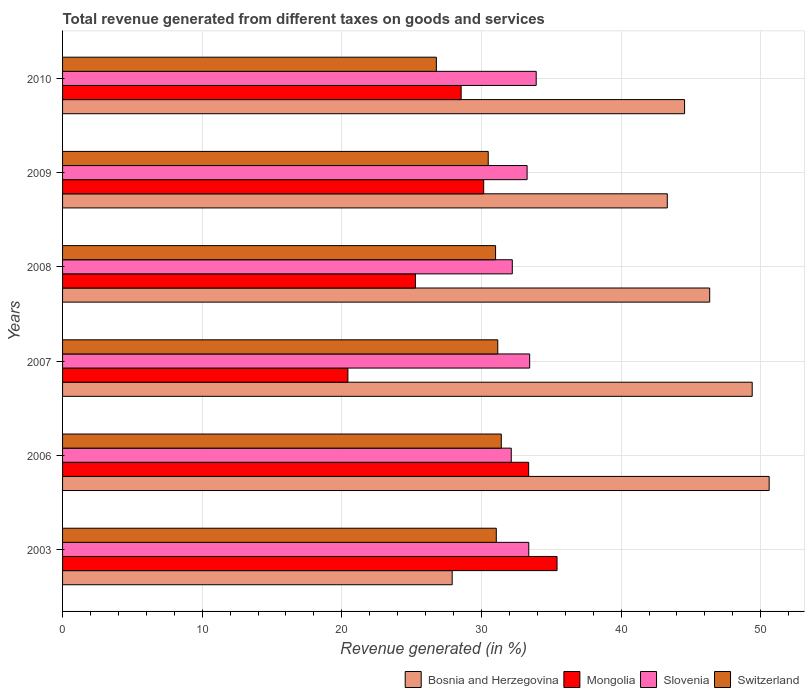Are the number of bars on each tick of the Y-axis equal?
Ensure brevity in your answer.  Yes. How many bars are there on the 2nd tick from the top?
Make the answer very short. 4. What is the label of the 1st group of bars from the top?
Provide a short and direct response. 2010. What is the total revenue generated in Switzerland in 2009?
Offer a terse response. 30.48. Across all years, what is the maximum total revenue generated in Bosnia and Herzegovina?
Offer a terse response. 50.6. Across all years, what is the minimum total revenue generated in Bosnia and Herzegovina?
Keep it short and to the point. 27.9. In which year was the total revenue generated in Slovenia minimum?
Provide a succinct answer. 2006. What is the total total revenue generated in Bosnia and Herzegovina in the graph?
Give a very brief answer. 262.08. What is the difference between the total revenue generated in Mongolia in 2007 and that in 2008?
Your answer should be very brief. -4.84. What is the difference between the total revenue generated in Slovenia in 2006 and the total revenue generated in Bosnia and Herzegovina in 2003?
Provide a short and direct response. 4.23. What is the average total revenue generated in Switzerland per year?
Your response must be concise. 30.32. In the year 2003, what is the difference between the total revenue generated in Switzerland and total revenue generated in Bosnia and Herzegovina?
Offer a terse response. 3.16. What is the ratio of the total revenue generated in Slovenia in 2009 to that in 2010?
Provide a succinct answer. 0.98. Is the difference between the total revenue generated in Switzerland in 2003 and 2009 greater than the difference between the total revenue generated in Bosnia and Herzegovina in 2003 and 2009?
Your answer should be very brief. Yes. What is the difference between the highest and the second highest total revenue generated in Slovenia?
Provide a short and direct response. 0.47. What is the difference between the highest and the lowest total revenue generated in Bosnia and Herzegovina?
Offer a very short reply. 22.7. In how many years, is the total revenue generated in Switzerland greater than the average total revenue generated in Switzerland taken over all years?
Your answer should be compact. 5. Is it the case that in every year, the sum of the total revenue generated in Switzerland and total revenue generated in Mongolia is greater than the sum of total revenue generated in Bosnia and Herzegovina and total revenue generated in Slovenia?
Ensure brevity in your answer.  No. What does the 3rd bar from the top in 2010 represents?
Give a very brief answer. Mongolia. What does the 1st bar from the bottom in 2010 represents?
Provide a short and direct response. Bosnia and Herzegovina. Is it the case that in every year, the sum of the total revenue generated in Bosnia and Herzegovina and total revenue generated in Switzerland is greater than the total revenue generated in Slovenia?
Your answer should be compact. Yes. How many years are there in the graph?
Offer a terse response. 6. What is the difference between two consecutive major ticks on the X-axis?
Keep it short and to the point. 10. Are the values on the major ticks of X-axis written in scientific E-notation?
Make the answer very short. No. How are the legend labels stacked?
Provide a short and direct response. Horizontal. What is the title of the graph?
Your response must be concise. Total revenue generated from different taxes on goods and services. What is the label or title of the X-axis?
Ensure brevity in your answer.  Revenue generated (in %). What is the label or title of the Y-axis?
Your response must be concise. Years. What is the Revenue generated (in %) in Bosnia and Herzegovina in 2003?
Ensure brevity in your answer.  27.9. What is the Revenue generated (in %) of Mongolia in 2003?
Your answer should be compact. 35.41. What is the Revenue generated (in %) of Slovenia in 2003?
Your answer should be very brief. 33.39. What is the Revenue generated (in %) of Switzerland in 2003?
Provide a succinct answer. 31.06. What is the Revenue generated (in %) of Bosnia and Herzegovina in 2006?
Provide a short and direct response. 50.6. What is the Revenue generated (in %) of Mongolia in 2006?
Offer a very short reply. 33.38. What is the Revenue generated (in %) of Slovenia in 2006?
Your answer should be very brief. 32.13. What is the Revenue generated (in %) of Switzerland in 2006?
Make the answer very short. 31.42. What is the Revenue generated (in %) in Bosnia and Herzegovina in 2007?
Keep it short and to the point. 49.39. What is the Revenue generated (in %) of Mongolia in 2007?
Your answer should be very brief. 20.43. What is the Revenue generated (in %) of Slovenia in 2007?
Your answer should be very brief. 33.45. What is the Revenue generated (in %) of Switzerland in 2007?
Make the answer very short. 31.17. What is the Revenue generated (in %) of Bosnia and Herzegovina in 2008?
Provide a short and direct response. 46.34. What is the Revenue generated (in %) of Mongolia in 2008?
Ensure brevity in your answer.  25.27. What is the Revenue generated (in %) in Slovenia in 2008?
Offer a terse response. 32.21. What is the Revenue generated (in %) of Switzerland in 2008?
Offer a very short reply. 31.01. What is the Revenue generated (in %) in Bosnia and Herzegovina in 2009?
Your answer should be compact. 43.31. What is the Revenue generated (in %) in Mongolia in 2009?
Your answer should be compact. 30.16. What is the Revenue generated (in %) in Slovenia in 2009?
Provide a short and direct response. 33.27. What is the Revenue generated (in %) of Switzerland in 2009?
Your answer should be very brief. 30.48. What is the Revenue generated (in %) in Bosnia and Herzegovina in 2010?
Your response must be concise. 44.54. What is the Revenue generated (in %) in Mongolia in 2010?
Give a very brief answer. 28.54. What is the Revenue generated (in %) of Slovenia in 2010?
Make the answer very short. 33.92. What is the Revenue generated (in %) in Switzerland in 2010?
Ensure brevity in your answer.  26.77. Across all years, what is the maximum Revenue generated (in %) in Bosnia and Herzegovina?
Provide a succinct answer. 50.6. Across all years, what is the maximum Revenue generated (in %) of Mongolia?
Offer a very short reply. 35.41. Across all years, what is the maximum Revenue generated (in %) of Slovenia?
Keep it short and to the point. 33.92. Across all years, what is the maximum Revenue generated (in %) in Switzerland?
Keep it short and to the point. 31.42. Across all years, what is the minimum Revenue generated (in %) of Bosnia and Herzegovina?
Make the answer very short. 27.9. Across all years, what is the minimum Revenue generated (in %) of Mongolia?
Make the answer very short. 20.43. Across all years, what is the minimum Revenue generated (in %) of Slovenia?
Offer a very short reply. 32.13. Across all years, what is the minimum Revenue generated (in %) of Switzerland?
Your answer should be compact. 26.77. What is the total Revenue generated (in %) of Bosnia and Herzegovina in the graph?
Ensure brevity in your answer.  262.08. What is the total Revenue generated (in %) of Mongolia in the graph?
Offer a very short reply. 173.19. What is the total Revenue generated (in %) in Slovenia in the graph?
Give a very brief answer. 198.36. What is the total Revenue generated (in %) in Switzerland in the graph?
Your response must be concise. 181.91. What is the difference between the Revenue generated (in %) in Bosnia and Herzegovina in 2003 and that in 2006?
Make the answer very short. -22.7. What is the difference between the Revenue generated (in %) of Mongolia in 2003 and that in 2006?
Make the answer very short. 2.03. What is the difference between the Revenue generated (in %) of Slovenia in 2003 and that in 2006?
Give a very brief answer. 1.25. What is the difference between the Revenue generated (in %) of Switzerland in 2003 and that in 2006?
Keep it short and to the point. -0.36. What is the difference between the Revenue generated (in %) of Bosnia and Herzegovina in 2003 and that in 2007?
Make the answer very short. -21.48. What is the difference between the Revenue generated (in %) in Mongolia in 2003 and that in 2007?
Ensure brevity in your answer.  14.98. What is the difference between the Revenue generated (in %) in Slovenia in 2003 and that in 2007?
Your answer should be very brief. -0.06. What is the difference between the Revenue generated (in %) of Switzerland in 2003 and that in 2007?
Offer a terse response. -0.11. What is the difference between the Revenue generated (in %) in Bosnia and Herzegovina in 2003 and that in 2008?
Offer a terse response. -18.44. What is the difference between the Revenue generated (in %) of Mongolia in 2003 and that in 2008?
Offer a terse response. 10.14. What is the difference between the Revenue generated (in %) of Slovenia in 2003 and that in 2008?
Offer a terse response. 1.18. What is the difference between the Revenue generated (in %) in Switzerland in 2003 and that in 2008?
Offer a very short reply. 0.05. What is the difference between the Revenue generated (in %) of Bosnia and Herzegovina in 2003 and that in 2009?
Your answer should be very brief. -15.4. What is the difference between the Revenue generated (in %) in Mongolia in 2003 and that in 2009?
Make the answer very short. 5.25. What is the difference between the Revenue generated (in %) in Slovenia in 2003 and that in 2009?
Make the answer very short. 0.12. What is the difference between the Revenue generated (in %) in Switzerland in 2003 and that in 2009?
Offer a very short reply. 0.58. What is the difference between the Revenue generated (in %) in Bosnia and Herzegovina in 2003 and that in 2010?
Provide a short and direct response. -16.64. What is the difference between the Revenue generated (in %) in Mongolia in 2003 and that in 2010?
Offer a very short reply. 6.87. What is the difference between the Revenue generated (in %) in Slovenia in 2003 and that in 2010?
Offer a very short reply. -0.53. What is the difference between the Revenue generated (in %) of Switzerland in 2003 and that in 2010?
Offer a terse response. 4.29. What is the difference between the Revenue generated (in %) of Bosnia and Herzegovina in 2006 and that in 2007?
Ensure brevity in your answer.  1.21. What is the difference between the Revenue generated (in %) in Mongolia in 2006 and that in 2007?
Offer a terse response. 12.94. What is the difference between the Revenue generated (in %) in Slovenia in 2006 and that in 2007?
Your answer should be compact. -1.32. What is the difference between the Revenue generated (in %) in Switzerland in 2006 and that in 2007?
Provide a short and direct response. 0.25. What is the difference between the Revenue generated (in %) of Bosnia and Herzegovina in 2006 and that in 2008?
Ensure brevity in your answer.  4.26. What is the difference between the Revenue generated (in %) in Mongolia in 2006 and that in 2008?
Make the answer very short. 8.11. What is the difference between the Revenue generated (in %) in Slovenia in 2006 and that in 2008?
Give a very brief answer. -0.07. What is the difference between the Revenue generated (in %) of Switzerland in 2006 and that in 2008?
Your answer should be compact. 0.41. What is the difference between the Revenue generated (in %) in Bosnia and Herzegovina in 2006 and that in 2009?
Make the answer very short. 7.3. What is the difference between the Revenue generated (in %) in Mongolia in 2006 and that in 2009?
Offer a very short reply. 3.22. What is the difference between the Revenue generated (in %) in Slovenia in 2006 and that in 2009?
Make the answer very short. -1.13. What is the difference between the Revenue generated (in %) in Switzerland in 2006 and that in 2009?
Your answer should be compact. 0.94. What is the difference between the Revenue generated (in %) of Bosnia and Herzegovina in 2006 and that in 2010?
Offer a terse response. 6.06. What is the difference between the Revenue generated (in %) of Mongolia in 2006 and that in 2010?
Ensure brevity in your answer.  4.83. What is the difference between the Revenue generated (in %) of Slovenia in 2006 and that in 2010?
Your answer should be compact. -1.79. What is the difference between the Revenue generated (in %) of Switzerland in 2006 and that in 2010?
Give a very brief answer. 4.65. What is the difference between the Revenue generated (in %) of Bosnia and Herzegovina in 2007 and that in 2008?
Offer a terse response. 3.04. What is the difference between the Revenue generated (in %) in Mongolia in 2007 and that in 2008?
Provide a short and direct response. -4.84. What is the difference between the Revenue generated (in %) of Slovenia in 2007 and that in 2008?
Ensure brevity in your answer.  1.24. What is the difference between the Revenue generated (in %) in Switzerland in 2007 and that in 2008?
Keep it short and to the point. 0.16. What is the difference between the Revenue generated (in %) in Bosnia and Herzegovina in 2007 and that in 2009?
Provide a short and direct response. 6.08. What is the difference between the Revenue generated (in %) in Mongolia in 2007 and that in 2009?
Offer a very short reply. -9.73. What is the difference between the Revenue generated (in %) in Slovenia in 2007 and that in 2009?
Your response must be concise. 0.18. What is the difference between the Revenue generated (in %) in Switzerland in 2007 and that in 2009?
Provide a succinct answer. 0.68. What is the difference between the Revenue generated (in %) in Bosnia and Herzegovina in 2007 and that in 2010?
Ensure brevity in your answer.  4.84. What is the difference between the Revenue generated (in %) in Mongolia in 2007 and that in 2010?
Make the answer very short. -8.11. What is the difference between the Revenue generated (in %) in Slovenia in 2007 and that in 2010?
Your answer should be compact. -0.47. What is the difference between the Revenue generated (in %) in Switzerland in 2007 and that in 2010?
Your answer should be compact. 4.4. What is the difference between the Revenue generated (in %) of Bosnia and Herzegovina in 2008 and that in 2009?
Your answer should be very brief. 3.04. What is the difference between the Revenue generated (in %) of Mongolia in 2008 and that in 2009?
Your answer should be very brief. -4.89. What is the difference between the Revenue generated (in %) in Slovenia in 2008 and that in 2009?
Offer a terse response. -1.06. What is the difference between the Revenue generated (in %) in Switzerland in 2008 and that in 2009?
Your answer should be very brief. 0.53. What is the difference between the Revenue generated (in %) in Bosnia and Herzegovina in 2008 and that in 2010?
Offer a very short reply. 1.8. What is the difference between the Revenue generated (in %) in Mongolia in 2008 and that in 2010?
Your answer should be very brief. -3.27. What is the difference between the Revenue generated (in %) in Slovenia in 2008 and that in 2010?
Offer a very short reply. -1.71. What is the difference between the Revenue generated (in %) of Switzerland in 2008 and that in 2010?
Ensure brevity in your answer.  4.24. What is the difference between the Revenue generated (in %) of Bosnia and Herzegovina in 2009 and that in 2010?
Keep it short and to the point. -1.24. What is the difference between the Revenue generated (in %) in Mongolia in 2009 and that in 2010?
Give a very brief answer. 1.61. What is the difference between the Revenue generated (in %) of Slovenia in 2009 and that in 2010?
Keep it short and to the point. -0.65. What is the difference between the Revenue generated (in %) in Switzerland in 2009 and that in 2010?
Offer a very short reply. 3.71. What is the difference between the Revenue generated (in %) of Bosnia and Herzegovina in 2003 and the Revenue generated (in %) of Mongolia in 2006?
Your answer should be compact. -5.48. What is the difference between the Revenue generated (in %) in Bosnia and Herzegovina in 2003 and the Revenue generated (in %) in Slovenia in 2006?
Give a very brief answer. -4.23. What is the difference between the Revenue generated (in %) of Bosnia and Herzegovina in 2003 and the Revenue generated (in %) of Switzerland in 2006?
Offer a very short reply. -3.52. What is the difference between the Revenue generated (in %) of Mongolia in 2003 and the Revenue generated (in %) of Slovenia in 2006?
Provide a short and direct response. 3.28. What is the difference between the Revenue generated (in %) in Mongolia in 2003 and the Revenue generated (in %) in Switzerland in 2006?
Keep it short and to the point. 3.99. What is the difference between the Revenue generated (in %) in Slovenia in 2003 and the Revenue generated (in %) in Switzerland in 2006?
Provide a short and direct response. 1.97. What is the difference between the Revenue generated (in %) of Bosnia and Herzegovina in 2003 and the Revenue generated (in %) of Mongolia in 2007?
Ensure brevity in your answer.  7.47. What is the difference between the Revenue generated (in %) of Bosnia and Herzegovina in 2003 and the Revenue generated (in %) of Slovenia in 2007?
Provide a succinct answer. -5.55. What is the difference between the Revenue generated (in %) in Bosnia and Herzegovina in 2003 and the Revenue generated (in %) in Switzerland in 2007?
Provide a succinct answer. -3.26. What is the difference between the Revenue generated (in %) of Mongolia in 2003 and the Revenue generated (in %) of Slovenia in 2007?
Make the answer very short. 1.96. What is the difference between the Revenue generated (in %) in Mongolia in 2003 and the Revenue generated (in %) in Switzerland in 2007?
Your response must be concise. 4.24. What is the difference between the Revenue generated (in %) in Slovenia in 2003 and the Revenue generated (in %) in Switzerland in 2007?
Provide a short and direct response. 2.22. What is the difference between the Revenue generated (in %) of Bosnia and Herzegovina in 2003 and the Revenue generated (in %) of Mongolia in 2008?
Offer a very short reply. 2.63. What is the difference between the Revenue generated (in %) in Bosnia and Herzegovina in 2003 and the Revenue generated (in %) in Slovenia in 2008?
Provide a short and direct response. -4.3. What is the difference between the Revenue generated (in %) in Bosnia and Herzegovina in 2003 and the Revenue generated (in %) in Switzerland in 2008?
Your response must be concise. -3.11. What is the difference between the Revenue generated (in %) in Mongolia in 2003 and the Revenue generated (in %) in Slovenia in 2008?
Offer a very short reply. 3.2. What is the difference between the Revenue generated (in %) in Mongolia in 2003 and the Revenue generated (in %) in Switzerland in 2008?
Ensure brevity in your answer.  4.4. What is the difference between the Revenue generated (in %) in Slovenia in 2003 and the Revenue generated (in %) in Switzerland in 2008?
Ensure brevity in your answer.  2.38. What is the difference between the Revenue generated (in %) in Bosnia and Herzegovina in 2003 and the Revenue generated (in %) in Mongolia in 2009?
Keep it short and to the point. -2.26. What is the difference between the Revenue generated (in %) of Bosnia and Herzegovina in 2003 and the Revenue generated (in %) of Slovenia in 2009?
Give a very brief answer. -5.37. What is the difference between the Revenue generated (in %) of Bosnia and Herzegovina in 2003 and the Revenue generated (in %) of Switzerland in 2009?
Your response must be concise. -2.58. What is the difference between the Revenue generated (in %) in Mongolia in 2003 and the Revenue generated (in %) in Slovenia in 2009?
Your response must be concise. 2.14. What is the difference between the Revenue generated (in %) of Mongolia in 2003 and the Revenue generated (in %) of Switzerland in 2009?
Offer a terse response. 4.93. What is the difference between the Revenue generated (in %) of Slovenia in 2003 and the Revenue generated (in %) of Switzerland in 2009?
Give a very brief answer. 2.9. What is the difference between the Revenue generated (in %) in Bosnia and Herzegovina in 2003 and the Revenue generated (in %) in Mongolia in 2010?
Your response must be concise. -0.64. What is the difference between the Revenue generated (in %) of Bosnia and Herzegovina in 2003 and the Revenue generated (in %) of Slovenia in 2010?
Provide a short and direct response. -6.02. What is the difference between the Revenue generated (in %) in Bosnia and Herzegovina in 2003 and the Revenue generated (in %) in Switzerland in 2010?
Your answer should be compact. 1.13. What is the difference between the Revenue generated (in %) in Mongolia in 2003 and the Revenue generated (in %) in Slovenia in 2010?
Keep it short and to the point. 1.49. What is the difference between the Revenue generated (in %) in Mongolia in 2003 and the Revenue generated (in %) in Switzerland in 2010?
Keep it short and to the point. 8.64. What is the difference between the Revenue generated (in %) in Slovenia in 2003 and the Revenue generated (in %) in Switzerland in 2010?
Your answer should be very brief. 6.62. What is the difference between the Revenue generated (in %) of Bosnia and Herzegovina in 2006 and the Revenue generated (in %) of Mongolia in 2007?
Your answer should be very brief. 30.17. What is the difference between the Revenue generated (in %) in Bosnia and Herzegovina in 2006 and the Revenue generated (in %) in Slovenia in 2007?
Keep it short and to the point. 17.15. What is the difference between the Revenue generated (in %) of Bosnia and Herzegovina in 2006 and the Revenue generated (in %) of Switzerland in 2007?
Give a very brief answer. 19.43. What is the difference between the Revenue generated (in %) of Mongolia in 2006 and the Revenue generated (in %) of Slovenia in 2007?
Keep it short and to the point. -0.07. What is the difference between the Revenue generated (in %) in Mongolia in 2006 and the Revenue generated (in %) in Switzerland in 2007?
Your answer should be compact. 2.21. What is the difference between the Revenue generated (in %) in Slovenia in 2006 and the Revenue generated (in %) in Switzerland in 2007?
Make the answer very short. 0.97. What is the difference between the Revenue generated (in %) in Bosnia and Herzegovina in 2006 and the Revenue generated (in %) in Mongolia in 2008?
Your answer should be very brief. 25.33. What is the difference between the Revenue generated (in %) in Bosnia and Herzegovina in 2006 and the Revenue generated (in %) in Slovenia in 2008?
Provide a succinct answer. 18.39. What is the difference between the Revenue generated (in %) of Bosnia and Herzegovina in 2006 and the Revenue generated (in %) of Switzerland in 2008?
Offer a terse response. 19.59. What is the difference between the Revenue generated (in %) in Mongolia in 2006 and the Revenue generated (in %) in Slovenia in 2008?
Give a very brief answer. 1.17. What is the difference between the Revenue generated (in %) of Mongolia in 2006 and the Revenue generated (in %) of Switzerland in 2008?
Give a very brief answer. 2.37. What is the difference between the Revenue generated (in %) of Slovenia in 2006 and the Revenue generated (in %) of Switzerland in 2008?
Your answer should be very brief. 1.12. What is the difference between the Revenue generated (in %) in Bosnia and Herzegovina in 2006 and the Revenue generated (in %) in Mongolia in 2009?
Offer a very short reply. 20.44. What is the difference between the Revenue generated (in %) of Bosnia and Herzegovina in 2006 and the Revenue generated (in %) of Slovenia in 2009?
Offer a terse response. 17.33. What is the difference between the Revenue generated (in %) in Bosnia and Herzegovina in 2006 and the Revenue generated (in %) in Switzerland in 2009?
Keep it short and to the point. 20.12. What is the difference between the Revenue generated (in %) in Mongolia in 2006 and the Revenue generated (in %) in Slovenia in 2009?
Provide a succinct answer. 0.11. What is the difference between the Revenue generated (in %) in Mongolia in 2006 and the Revenue generated (in %) in Switzerland in 2009?
Give a very brief answer. 2.89. What is the difference between the Revenue generated (in %) in Slovenia in 2006 and the Revenue generated (in %) in Switzerland in 2009?
Ensure brevity in your answer.  1.65. What is the difference between the Revenue generated (in %) of Bosnia and Herzegovina in 2006 and the Revenue generated (in %) of Mongolia in 2010?
Ensure brevity in your answer.  22.06. What is the difference between the Revenue generated (in %) in Bosnia and Herzegovina in 2006 and the Revenue generated (in %) in Slovenia in 2010?
Provide a succinct answer. 16.68. What is the difference between the Revenue generated (in %) of Bosnia and Herzegovina in 2006 and the Revenue generated (in %) of Switzerland in 2010?
Your answer should be very brief. 23.83. What is the difference between the Revenue generated (in %) of Mongolia in 2006 and the Revenue generated (in %) of Slovenia in 2010?
Provide a succinct answer. -0.54. What is the difference between the Revenue generated (in %) of Mongolia in 2006 and the Revenue generated (in %) of Switzerland in 2010?
Your answer should be compact. 6.61. What is the difference between the Revenue generated (in %) in Slovenia in 2006 and the Revenue generated (in %) in Switzerland in 2010?
Offer a terse response. 5.36. What is the difference between the Revenue generated (in %) of Bosnia and Herzegovina in 2007 and the Revenue generated (in %) of Mongolia in 2008?
Ensure brevity in your answer.  24.12. What is the difference between the Revenue generated (in %) in Bosnia and Herzegovina in 2007 and the Revenue generated (in %) in Slovenia in 2008?
Make the answer very short. 17.18. What is the difference between the Revenue generated (in %) in Bosnia and Herzegovina in 2007 and the Revenue generated (in %) in Switzerland in 2008?
Offer a very short reply. 18.38. What is the difference between the Revenue generated (in %) of Mongolia in 2007 and the Revenue generated (in %) of Slovenia in 2008?
Offer a very short reply. -11.77. What is the difference between the Revenue generated (in %) in Mongolia in 2007 and the Revenue generated (in %) in Switzerland in 2008?
Your answer should be compact. -10.58. What is the difference between the Revenue generated (in %) in Slovenia in 2007 and the Revenue generated (in %) in Switzerland in 2008?
Your answer should be compact. 2.44. What is the difference between the Revenue generated (in %) in Bosnia and Herzegovina in 2007 and the Revenue generated (in %) in Mongolia in 2009?
Your answer should be compact. 19.23. What is the difference between the Revenue generated (in %) of Bosnia and Herzegovina in 2007 and the Revenue generated (in %) of Slovenia in 2009?
Provide a short and direct response. 16.12. What is the difference between the Revenue generated (in %) in Bosnia and Herzegovina in 2007 and the Revenue generated (in %) in Switzerland in 2009?
Offer a very short reply. 18.9. What is the difference between the Revenue generated (in %) in Mongolia in 2007 and the Revenue generated (in %) in Slovenia in 2009?
Provide a short and direct response. -12.83. What is the difference between the Revenue generated (in %) of Mongolia in 2007 and the Revenue generated (in %) of Switzerland in 2009?
Your answer should be very brief. -10.05. What is the difference between the Revenue generated (in %) of Slovenia in 2007 and the Revenue generated (in %) of Switzerland in 2009?
Offer a terse response. 2.97. What is the difference between the Revenue generated (in %) of Bosnia and Herzegovina in 2007 and the Revenue generated (in %) of Mongolia in 2010?
Your answer should be compact. 20.84. What is the difference between the Revenue generated (in %) of Bosnia and Herzegovina in 2007 and the Revenue generated (in %) of Slovenia in 2010?
Make the answer very short. 15.47. What is the difference between the Revenue generated (in %) in Bosnia and Herzegovina in 2007 and the Revenue generated (in %) in Switzerland in 2010?
Your answer should be compact. 22.62. What is the difference between the Revenue generated (in %) in Mongolia in 2007 and the Revenue generated (in %) in Slovenia in 2010?
Make the answer very short. -13.49. What is the difference between the Revenue generated (in %) in Mongolia in 2007 and the Revenue generated (in %) in Switzerland in 2010?
Provide a short and direct response. -6.34. What is the difference between the Revenue generated (in %) in Slovenia in 2007 and the Revenue generated (in %) in Switzerland in 2010?
Offer a terse response. 6.68. What is the difference between the Revenue generated (in %) of Bosnia and Herzegovina in 2008 and the Revenue generated (in %) of Mongolia in 2009?
Your answer should be very brief. 16.18. What is the difference between the Revenue generated (in %) of Bosnia and Herzegovina in 2008 and the Revenue generated (in %) of Slovenia in 2009?
Your answer should be very brief. 13.07. What is the difference between the Revenue generated (in %) of Bosnia and Herzegovina in 2008 and the Revenue generated (in %) of Switzerland in 2009?
Offer a terse response. 15.86. What is the difference between the Revenue generated (in %) of Mongolia in 2008 and the Revenue generated (in %) of Slovenia in 2009?
Your answer should be very brief. -8. What is the difference between the Revenue generated (in %) in Mongolia in 2008 and the Revenue generated (in %) in Switzerland in 2009?
Your response must be concise. -5.21. What is the difference between the Revenue generated (in %) in Slovenia in 2008 and the Revenue generated (in %) in Switzerland in 2009?
Ensure brevity in your answer.  1.72. What is the difference between the Revenue generated (in %) in Bosnia and Herzegovina in 2008 and the Revenue generated (in %) in Mongolia in 2010?
Provide a succinct answer. 17.8. What is the difference between the Revenue generated (in %) of Bosnia and Herzegovina in 2008 and the Revenue generated (in %) of Slovenia in 2010?
Provide a succinct answer. 12.42. What is the difference between the Revenue generated (in %) of Bosnia and Herzegovina in 2008 and the Revenue generated (in %) of Switzerland in 2010?
Keep it short and to the point. 19.57. What is the difference between the Revenue generated (in %) of Mongolia in 2008 and the Revenue generated (in %) of Slovenia in 2010?
Offer a terse response. -8.65. What is the difference between the Revenue generated (in %) of Mongolia in 2008 and the Revenue generated (in %) of Switzerland in 2010?
Your answer should be very brief. -1.5. What is the difference between the Revenue generated (in %) in Slovenia in 2008 and the Revenue generated (in %) in Switzerland in 2010?
Give a very brief answer. 5.44. What is the difference between the Revenue generated (in %) in Bosnia and Herzegovina in 2009 and the Revenue generated (in %) in Mongolia in 2010?
Keep it short and to the point. 14.76. What is the difference between the Revenue generated (in %) in Bosnia and Herzegovina in 2009 and the Revenue generated (in %) in Slovenia in 2010?
Keep it short and to the point. 9.39. What is the difference between the Revenue generated (in %) of Bosnia and Herzegovina in 2009 and the Revenue generated (in %) of Switzerland in 2010?
Make the answer very short. 16.54. What is the difference between the Revenue generated (in %) in Mongolia in 2009 and the Revenue generated (in %) in Slovenia in 2010?
Your answer should be compact. -3.76. What is the difference between the Revenue generated (in %) of Mongolia in 2009 and the Revenue generated (in %) of Switzerland in 2010?
Your answer should be very brief. 3.39. What is the difference between the Revenue generated (in %) in Slovenia in 2009 and the Revenue generated (in %) in Switzerland in 2010?
Offer a terse response. 6.5. What is the average Revenue generated (in %) in Bosnia and Herzegovina per year?
Your answer should be compact. 43.68. What is the average Revenue generated (in %) in Mongolia per year?
Keep it short and to the point. 28.87. What is the average Revenue generated (in %) in Slovenia per year?
Your response must be concise. 33.06. What is the average Revenue generated (in %) in Switzerland per year?
Provide a short and direct response. 30.32. In the year 2003, what is the difference between the Revenue generated (in %) of Bosnia and Herzegovina and Revenue generated (in %) of Mongolia?
Ensure brevity in your answer.  -7.51. In the year 2003, what is the difference between the Revenue generated (in %) in Bosnia and Herzegovina and Revenue generated (in %) in Slovenia?
Make the answer very short. -5.48. In the year 2003, what is the difference between the Revenue generated (in %) of Bosnia and Herzegovina and Revenue generated (in %) of Switzerland?
Your answer should be very brief. -3.16. In the year 2003, what is the difference between the Revenue generated (in %) in Mongolia and Revenue generated (in %) in Slovenia?
Your answer should be very brief. 2.02. In the year 2003, what is the difference between the Revenue generated (in %) in Mongolia and Revenue generated (in %) in Switzerland?
Keep it short and to the point. 4.35. In the year 2003, what is the difference between the Revenue generated (in %) in Slovenia and Revenue generated (in %) in Switzerland?
Offer a terse response. 2.33. In the year 2006, what is the difference between the Revenue generated (in %) of Bosnia and Herzegovina and Revenue generated (in %) of Mongolia?
Give a very brief answer. 17.22. In the year 2006, what is the difference between the Revenue generated (in %) of Bosnia and Herzegovina and Revenue generated (in %) of Slovenia?
Offer a terse response. 18.47. In the year 2006, what is the difference between the Revenue generated (in %) of Bosnia and Herzegovina and Revenue generated (in %) of Switzerland?
Make the answer very short. 19.18. In the year 2006, what is the difference between the Revenue generated (in %) of Mongolia and Revenue generated (in %) of Slovenia?
Your answer should be very brief. 1.25. In the year 2006, what is the difference between the Revenue generated (in %) in Mongolia and Revenue generated (in %) in Switzerland?
Keep it short and to the point. 1.96. In the year 2006, what is the difference between the Revenue generated (in %) of Slovenia and Revenue generated (in %) of Switzerland?
Your answer should be very brief. 0.71. In the year 2007, what is the difference between the Revenue generated (in %) in Bosnia and Herzegovina and Revenue generated (in %) in Mongolia?
Provide a short and direct response. 28.95. In the year 2007, what is the difference between the Revenue generated (in %) of Bosnia and Herzegovina and Revenue generated (in %) of Slovenia?
Your answer should be compact. 15.94. In the year 2007, what is the difference between the Revenue generated (in %) in Bosnia and Herzegovina and Revenue generated (in %) in Switzerland?
Make the answer very short. 18.22. In the year 2007, what is the difference between the Revenue generated (in %) of Mongolia and Revenue generated (in %) of Slovenia?
Give a very brief answer. -13.02. In the year 2007, what is the difference between the Revenue generated (in %) of Mongolia and Revenue generated (in %) of Switzerland?
Provide a short and direct response. -10.73. In the year 2007, what is the difference between the Revenue generated (in %) of Slovenia and Revenue generated (in %) of Switzerland?
Keep it short and to the point. 2.28. In the year 2008, what is the difference between the Revenue generated (in %) of Bosnia and Herzegovina and Revenue generated (in %) of Mongolia?
Ensure brevity in your answer.  21.07. In the year 2008, what is the difference between the Revenue generated (in %) of Bosnia and Herzegovina and Revenue generated (in %) of Slovenia?
Give a very brief answer. 14.14. In the year 2008, what is the difference between the Revenue generated (in %) in Bosnia and Herzegovina and Revenue generated (in %) in Switzerland?
Ensure brevity in your answer.  15.33. In the year 2008, what is the difference between the Revenue generated (in %) in Mongolia and Revenue generated (in %) in Slovenia?
Your answer should be compact. -6.93. In the year 2008, what is the difference between the Revenue generated (in %) in Mongolia and Revenue generated (in %) in Switzerland?
Your answer should be very brief. -5.74. In the year 2008, what is the difference between the Revenue generated (in %) in Slovenia and Revenue generated (in %) in Switzerland?
Offer a terse response. 1.2. In the year 2009, what is the difference between the Revenue generated (in %) of Bosnia and Herzegovina and Revenue generated (in %) of Mongolia?
Your answer should be very brief. 13.15. In the year 2009, what is the difference between the Revenue generated (in %) of Bosnia and Herzegovina and Revenue generated (in %) of Slovenia?
Offer a terse response. 10.04. In the year 2009, what is the difference between the Revenue generated (in %) of Bosnia and Herzegovina and Revenue generated (in %) of Switzerland?
Ensure brevity in your answer.  12.82. In the year 2009, what is the difference between the Revenue generated (in %) in Mongolia and Revenue generated (in %) in Slovenia?
Make the answer very short. -3.11. In the year 2009, what is the difference between the Revenue generated (in %) in Mongolia and Revenue generated (in %) in Switzerland?
Your answer should be compact. -0.33. In the year 2009, what is the difference between the Revenue generated (in %) in Slovenia and Revenue generated (in %) in Switzerland?
Give a very brief answer. 2.78. In the year 2010, what is the difference between the Revenue generated (in %) of Bosnia and Herzegovina and Revenue generated (in %) of Mongolia?
Offer a terse response. 16. In the year 2010, what is the difference between the Revenue generated (in %) of Bosnia and Herzegovina and Revenue generated (in %) of Slovenia?
Make the answer very short. 10.63. In the year 2010, what is the difference between the Revenue generated (in %) of Bosnia and Herzegovina and Revenue generated (in %) of Switzerland?
Offer a very short reply. 17.78. In the year 2010, what is the difference between the Revenue generated (in %) of Mongolia and Revenue generated (in %) of Slovenia?
Keep it short and to the point. -5.37. In the year 2010, what is the difference between the Revenue generated (in %) in Mongolia and Revenue generated (in %) in Switzerland?
Provide a short and direct response. 1.77. In the year 2010, what is the difference between the Revenue generated (in %) in Slovenia and Revenue generated (in %) in Switzerland?
Provide a succinct answer. 7.15. What is the ratio of the Revenue generated (in %) of Bosnia and Herzegovina in 2003 to that in 2006?
Your answer should be very brief. 0.55. What is the ratio of the Revenue generated (in %) of Mongolia in 2003 to that in 2006?
Offer a terse response. 1.06. What is the ratio of the Revenue generated (in %) in Slovenia in 2003 to that in 2006?
Your answer should be very brief. 1.04. What is the ratio of the Revenue generated (in %) of Switzerland in 2003 to that in 2006?
Ensure brevity in your answer.  0.99. What is the ratio of the Revenue generated (in %) in Bosnia and Herzegovina in 2003 to that in 2007?
Ensure brevity in your answer.  0.56. What is the ratio of the Revenue generated (in %) in Mongolia in 2003 to that in 2007?
Keep it short and to the point. 1.73. What is the ratio of the Revenue generated (in %) in Slovenia in 2003 to that in 2007?
Make the answer very short. 1. What is the ratio of the Revenue generated (in %) of Bosnia and Herzegovina in 2003 to that in 2008?
Your answer should be compact. 0.6. What is the ratio of the Revenue generated (in %) in Mongolia in 2003 to that in 2008?
Provide a short and direct response. 1.4. What is the ratio of the Revenue generated (in %) in Slovenia in 2003 to that in 2008?
Give a very brief answer. 1.04. What is the ratio of the Revenue generated (in %) of Bosnia and Herzegovina in 2003 to that in 2009?
Your answer should be compact. 0.64. What is the ratio of the Revenue generated (in %) in Mongolia in 2003 to that in 2009?
Keep it short and to the point. 1.17. What is the ratio of the Revenue generated (in %) of Switzerland in 2003 to that in 2009?
Offer a very short reply. 1.02. What is the ratio of the Revenue generated (in %) of Bosnia and Herzegovina in 2003 to that in 2010?
Your answer should be very brief. 0.63. What is the ratio of the Revenue generated (in %) in Mongolia in 2003 to that in 2010?
Provide a short and direct response. 1.24. What is the ratio of the Revenue generated (in %) in Slovenia in 2003 to that in 2010?
Your response must be concise. 0.98. What is the ratio of the Revenue generated (in %) of Switzerland in 2003 to that in 2010?
Give a very brief answer. 1.16. What is the ratio of the Revenue generated (in %) in Bosnia and Herzegovina in 2006 to that in 2007?
Your response must be concise. 1.02. What is the ratio of the Revenue generated (in %) of Mongolia in 2006 to that in 2007?
Your response must be concise. 1.63. What is the ratio of the Revenue generated (in %) in Slovenia in 2006 to that in 2007?
Provide a succinct answer. 0.96. What is the ratio of the Revenue generated (in %) of Bosnia and Herzegovina in 2006 to that in 2008?
Offer a very short reply. 1.09. What is the ratio of the Revenue generated (in %) in Mongolia in 2006 to that in 2008?
Your response must be concise. 1.32. What is the ratio of the Revenue generated (in %) of Switzerland in 2006 to that in 2008?
Make the answer very short. 1.01. What is the ratio of the Revenue generated (in %) of Bosnia and Herzegovina in 2006 to that in 2009?
Your answer should be compact. 1.17. What is the ratio of the Revenue generated (in %) in Mongolia in 2006 to that in 2009?
Make the answer very short. 1.11. What is the ratio of the Revenue generated (in %) in Slovenia in 2006 to that in 2009?
Make the answer very short. 0.97. What is the ratio of the Revenue generated (in %) of Switzerland in 2006 to that in 2009?
Make the answer very short. 1.03. What is the ratio of the Revenue generated (in %) in Bosnia and Herzegovina in 2006 to that in 2010?
Ensure brevity in your answer.  1.14. What is the ratio of the Revenue generated (in %) in Mongolia in 2006 to that in 2010?
Your answer should be compact. 1.17. What is the ratio of the Revenue generated (in %) in Switzerland in 2006 to that in 2010?
Offer a terse response. 1.17. What is the ratio of the Revenue generated (in %) of Bosnia and Herzegovina in 2007 to that in 2008?
Provide a succinct answer. 1.07. What is the ratio of the Revenue generated (in %) of Mongolia in 2007 to that in 2008?
Provide a succinct answer. 0.81. What is the ratio of the Revenue generated (in %) in Slovenia in 2007 to that in 2008?
Your response must be concise. 1.04. What is the ratio of the Revenue generated (in %) in Switzerland in 2007 to that in 2008?
Provide a short and direct response. 1.01. What is the ratio of the Revenue generated (in %) of Bosnia and Herzegovina in 2007 to that in 2009?
Your answer should be very brief. 1.14. What is the ratio of the Revenue generated (in %) of Mongolia in 2007 to that in 2009?
Provide a succinct answer. 0.68. What is the ratio of the Revenue generated (in %) in Switzerland in 2007 to that in 2009?
Your answer should be compact. 1.02. What is the ratio of the Revenue generated (in %) in Bosnia and Herzegovina in 2007 to that in 2010?
Provide a short and direct response. 1.11. What is the ratio of the Revenue generated (in %) of Mongolia in 2007 to that in 2010?
Offer a terse response. 0.72. What is the ratio of the Revenue generated (in %) of Slovenia in 2007 to that in 2010?
Your answer should be compact. 0.99. What is the ratio of the Revenue generated (in %) of Switzerland in 2007 to that in 2010?
Give a very brief answer. 1.16. What is the ratio of the Revenue generated (in %) of Bosnia and Herzegovina in 2008 to that in 2009?
Your response must be concise. 1.07. What is the ratio of the Revenue generated (in %) in Mongolia in 2008 to that in 2009?
Provide a succinct answer. 0.84. What is the ratio of the Revenue generated (in %) in Slovenia in 2008 to that in 2009?
Offer a very short reply. 0.97. What is the ratio of the Revenue generated (in %) in Switzerland in 2008 to that in 2009?
Make the answer very short. 1.02. What is the ratio of the Revenue generated (in %) in Bosnia and Herzegovina in 2008 to that in 2010?
Provide a short and direct response. 1.04. What is the ratio of the Revenue generated (in %) in Mongolia in 2008 to that in 2010?
Offer a terse response. 0.89. What is the ratio of the Revenue generated (in %) of Slovenia in 2008 to that in 2010?
Your answer should be very brief. 0.95. What is the ratio of the Revenue generated (in %) in Switzerland in 2008 to that in 2010?
Your response must be concise. 1.16. What is the ratio of the Revenue generated (in %) in Bosnia and Herzegovina in 2009 to that in 2010?
Provide a succinct answer. 0.97. What is the ratio of the Revenue generated (in %) of Mongolia in 2009 to that in 2010?
Offer a terse response. 1.06. What is the ratio of the Revenue generated (in %) of Slovenia in 2009 to that in 2010?
Offer a very short reply. 0.98. What is the ratio of the Revenue generated (in %) of Switzerland in 2009 to that in 2010?
Ensure brevity in your answer.  1.14. What is the difference between the highest and the second highest Revenue generated (in %) in Bosnia and Herzegovina?
Your response must be concise. 1.21. What is the difference between the highest and the second highest Revenue generated (in %) of Mongolia?
Ensure brevity in your answer.  2.03. What is the difference between the highest and the second highest Revenue generated (in %) of Slovenia?
Your answer should be very brief. 0.47. What is the difference between the highest and the second highest Revenue generated (in %) in Switzerland?
Offer a terse response. 0.25. What is the difference between the highest and the lowest Revenue generated (in %) of Bosnia and Herzegovina?
Provide a succinct answer. 22.7. What is the difference between the highest and the lowest Revenue generated (in %) in Mongolia?
Your answer should be very brief. 14.98. What is the difference between the highest and the lowest Revenue generated (in %) of Slovenia?
Ensure brevity in your answer.  1.79. What is the difference between the highest and the lowest Revenue generated (in %) of Switzerland?
Make the answer very short. 4.65. 